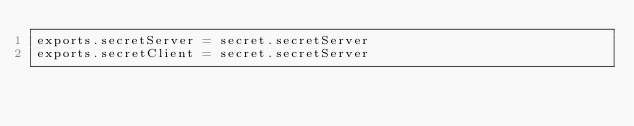<code> <loc_0><loc_0><loc_500><loc_500><_JavaScript_>exports.secretServer = secret.secretServer
exports.secretClient = secret.secretServer</code> 